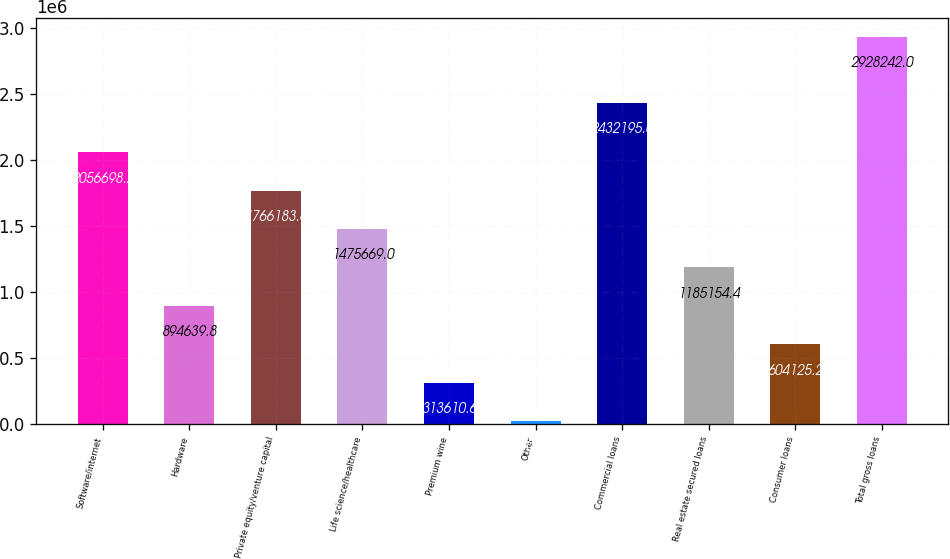Convert chart. <chart><loc_0><loc_0><loc_500><loc_500><bar_chart><fcel>Software/internet<fcel>Hardware<fcel>Private equity/venture capital<fcel>Life science/healthcare<fcel>Premium wine<fcel>Other<fcel>Commercial loans<fcel>Real estate secured loans<fcel>Consumer loans<fcel>Total gross loans<nl><fcel>2.0567e+06<fcel>894640<fcel>1.76618e+06<fcel>1.47567e+06<fcel>313611<fcel>23096<fcel>2.4322e+06<fcel>1.18515e+06<fcel>604125<fcel>2.92824e+06<nl></chart> 